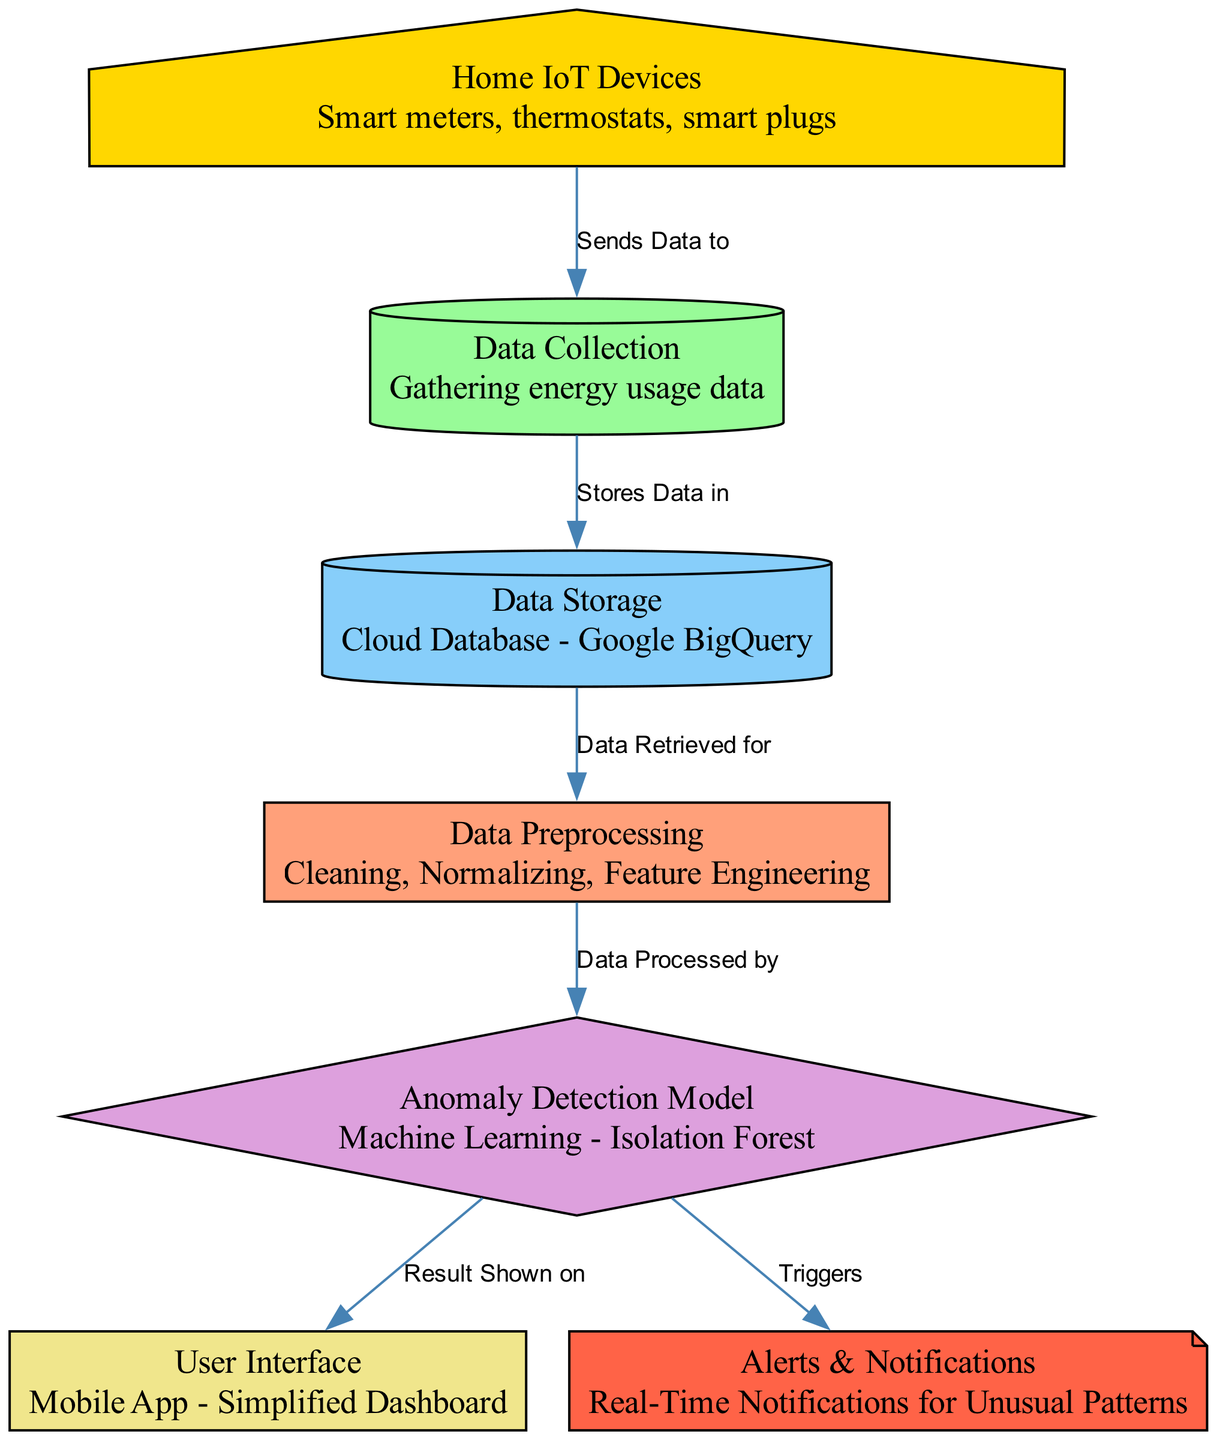What types of devices are included in the home IoT devices? The diagram lists "Smart meters, thermostats, smart plugs" under the "Home IoT Devices" node, indicating these are the devices involved.
Answer: Smart meters, thermostats, smart plugs How many nodes are there in the diagram? By counting the "nodes" in the provided data, there are a total of seven nodes in the diagram.
Answer: 7 What is the primary function of the "Data Collection" node? The "Data Collection" node represents the gathering of energy usage data, as described directly in the node information.
Answer: Gathering energy usage data Which node directly triggers real-time notifications? The "Alerts & Notifications" node is mentioned as the one that receives triggers from the "Anomaly Detection Model" indicating it is responsible for sending notifications.
Answer: Alerts & Notifications What process occurs after data is collected? The diagram indicates that after data is collected, it is stored in the "Cloud Database - Google BigQuery" which is the next node in the flow.
Answer: Stores Data in Which model is used for anomaly detection in this system? According to the diagram, the "Anomaly Detection Model" is specified as using the "Isolation Forest" method for identifying unusual consumption patterns.
Answer: Isolation Forest What type of interface is shown in the diagram for user interaction? The "User Interface" node specifies that a "Mobile App - Simplified Dashboard" is the means of user interaction depicted in the diagram.
Answer: Mobile App - Simplified Dashboard Which two nodes are connected to show a flow of processed data? The connection flows from the "Data Preprocessing" node to the "Anomaly Detection Model" node, indicating the transition of processed data.
Answer: Data Preprocessing to Anomaly Detection Model What happens to the data once it is processed by the anomaly detection model? Once processed, the anomaly detection model sends the results to both the "User Interface" and triggers the "Alerts & Notifications".
Answer: Shown on User Interface, Triggers Alerts & Notifications 